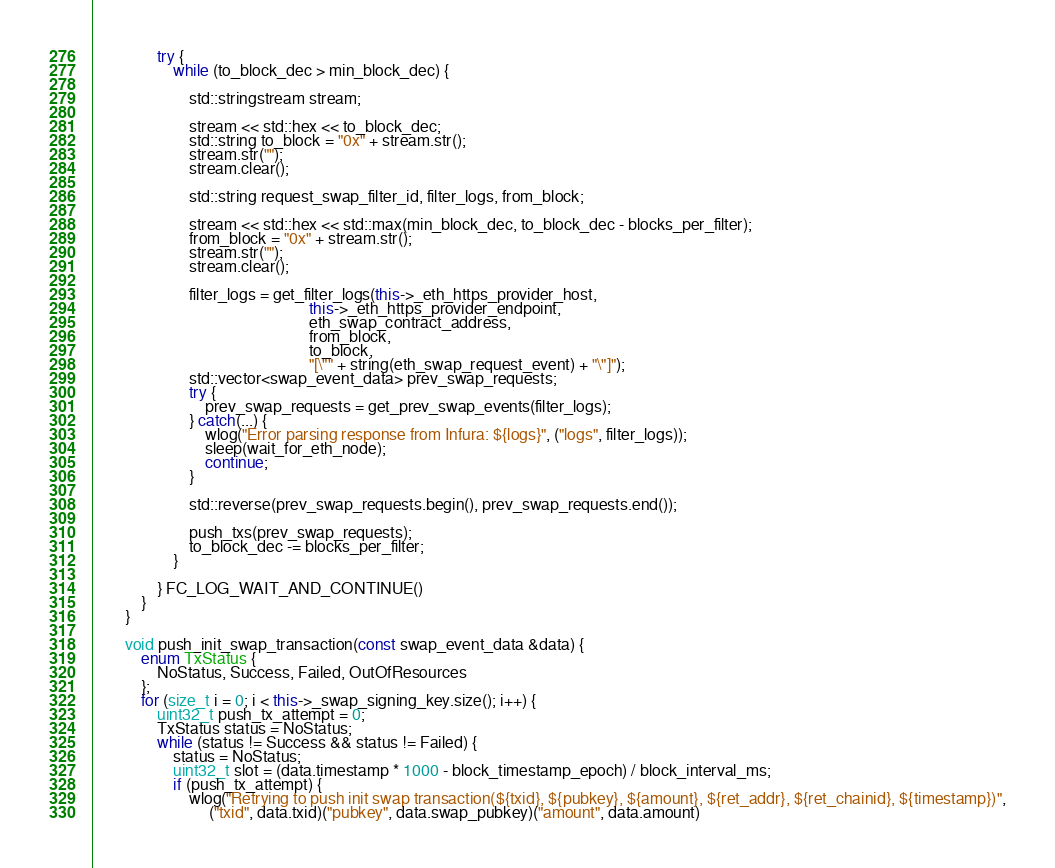Convert code to text. <code><loc_0><loc_0><loc_500><loc_500><_C++_>                try {
                    while (to_block_dec > min_block_dec) {

                        std::stringstream stream;

                        stream << std::hex << to_block_dec;
                        std::string to_block = "0x" + stream.str();
                        stream.str("");
                        stream.clear();

                        std::string request_swap_filter_id, filter_logs, from_block;

                        stream << std::hex << std::max(min_block_dec, to_block_dec - blocks_per_filter);
                        from_block = "0x" + stream.str();
                        stream.str("");
                        stream.clear();

                        filter_logs = get_filter_logs(this->_eth_https_provider_host,
                                                      this->_eth_https_provider_endpoint,
                                                      eth_swap_contract_address,
                                                      from_block,
                                                      to_block,
                                                      "[\"" + string(eth_swap_request_event) + "\"]");
                        std::vector<swap_event_data> prev_swap_requests;
                        try {
                            prev_swap_requests = get_prev_swap_events(filter_logs);
                        } catch(...) {
                            wlog("Error parsing response from Infura: ${logs}", ("logs", filter_logs));
                            sleep(wait_for_eth_node);
                            continue;
                        }

                        std::reverse(prev_swap_requests.begin(), prev_swap_requests.end());

                        push_txs(prev_swap_requests);
                        to_block_dec -= blocks_per_filter;
                    }

                } FC_LOG_WAIT_AND_CONTINUE()
            }
        }

        void push_init_swap_transaction(const swap_event_data &data) {
            enum TxStatus {
                NoStatus, Success, Failed, OutOfResources
            };
            for (size_t i = 0; i < this->_swap_signing_key.size(); i++) {
                uint32_t push_tx_attempt = 0;
                TxStatus status = NoStatus;
                while (status != Success && status != Failed) {
                    status = NoStatus;
                    uint32_t slot = (data.timestamp * 1000 - block_timestamp_epoch) / block_interval_ms;
                    if (push_tx_attempt) {
                        wlog("Retrying to push init swap transaction(${txid}, ${pubkey}, ${amount}, ${ret_addr}, ${ret_chainid}, ${timestamp})",
                             ("txid", data.txid)("pubkey", data.swap_pubkey)("amount", data.amount)</code> 